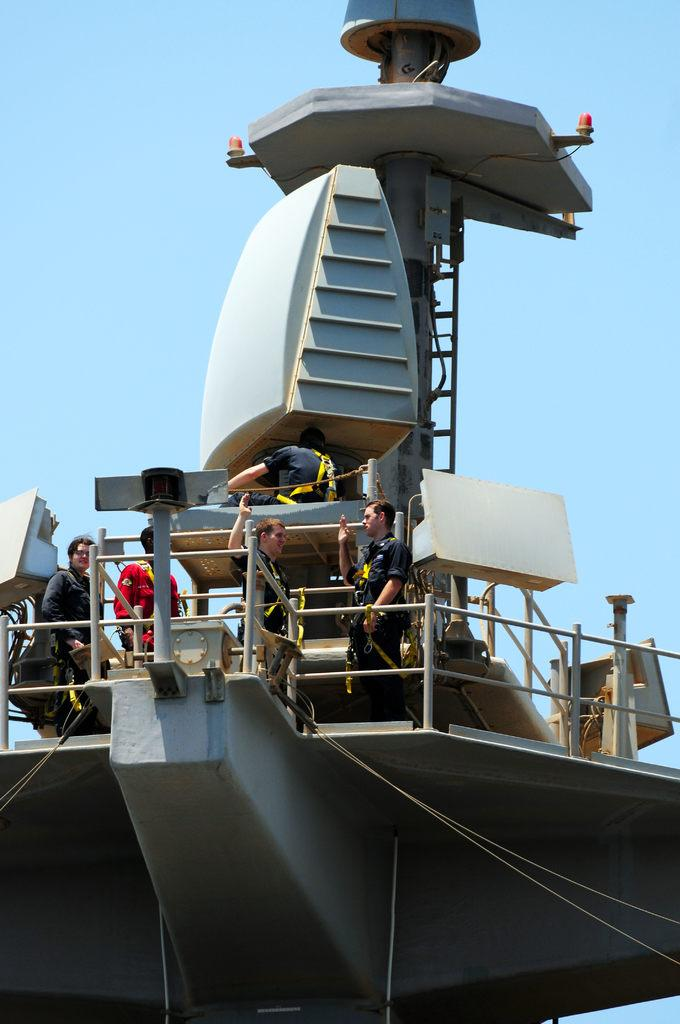What type of structure is depicted in the image? There is an object with railings, poles, and a ladder in the image. How many people are present in the image? There are many people in the image. What can be seen in the background of the image? The sky is visible in the background of the image. What else is present in the image besides the structure and people? There are tapes in the image. What type of feast is being prepared by the people in the image? There is no indication of a feast or any food preparation in the image. Can you see a bear interacting with the people in the image? There is no bear present in the image. 